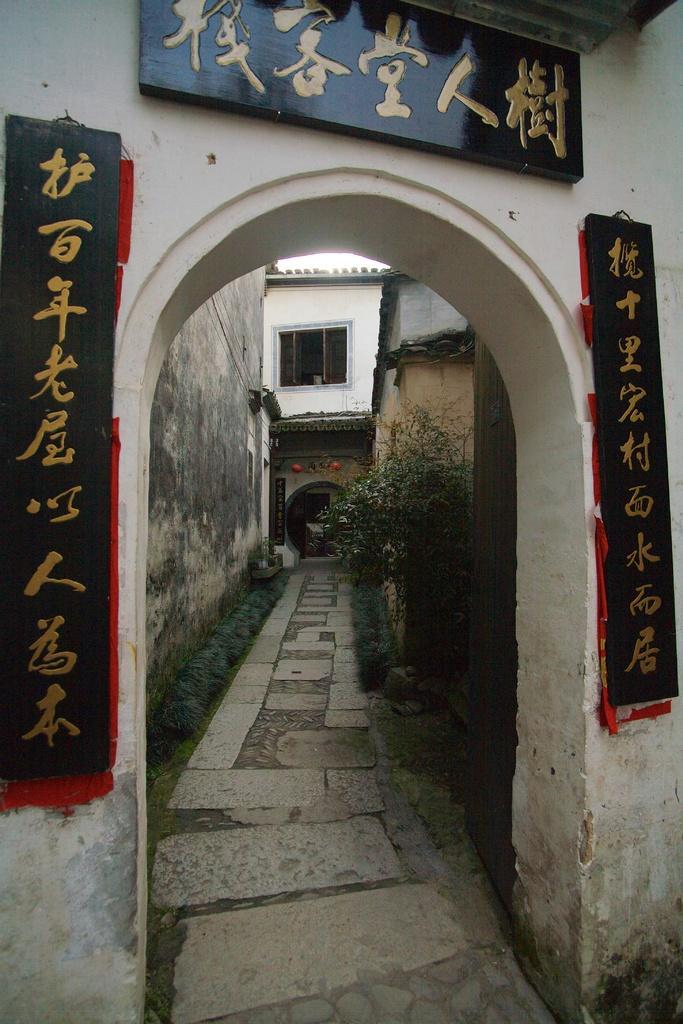In one or two sentences, can you explain what this image depicts? In the image in the center there is an arch and banners. In the background there is a building, wall, window, grass, plants etc. 